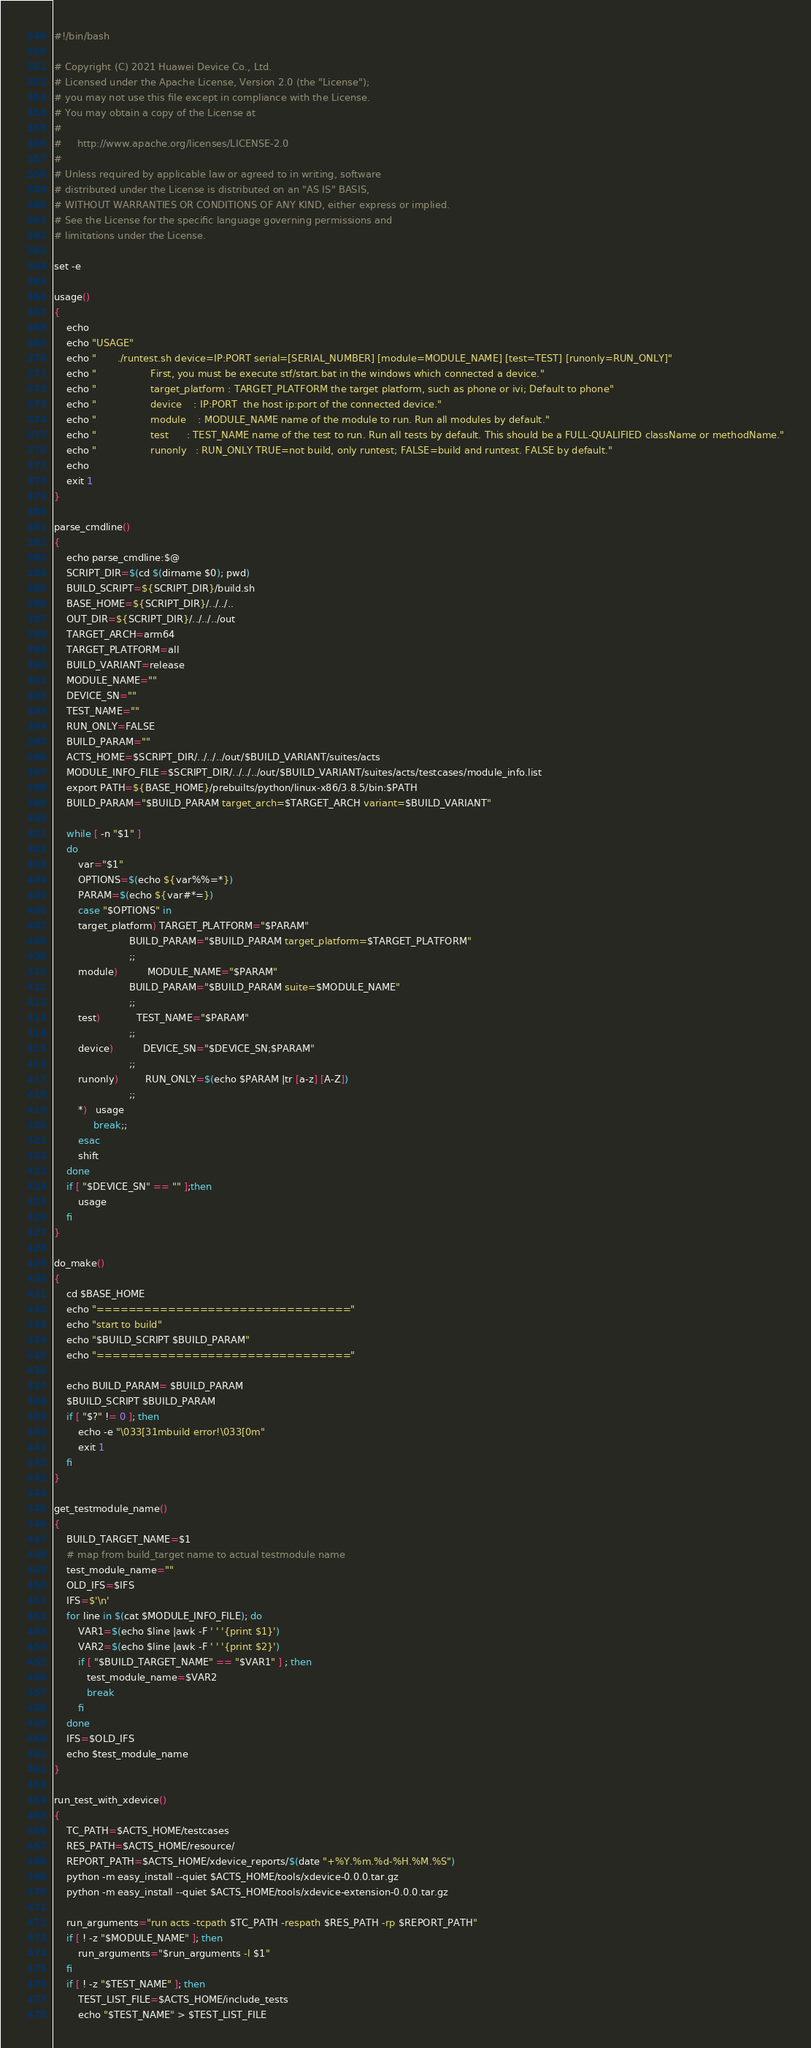Convert code to text. <code><loc_0><loc_0><loc_500><loc_500><_Bash_>#!/bin/bash

# Copyright (C) 2021 Huawei Device Co., Ltd.
# Licensed under the Apache License, Version 2.0 (the "License");
# you may not use this file except in compliance with the License.
# You may obtain a copy of the License at
#
#     http://www.apache.org/licenses/LICENSE-2.0
#
# Unless required by applicable law or agreed to in writing, software
# distributed under the License is distributed on an "AS IS" BASIS,
# WITHOUT WARRANTIES OR CONDITIONS OF ANY KIND, either express or implied.
# See the License for the specific language governing permissions and
# limitations under the License.

set -e

usage()
{
    echo
    echo "USAGE"
    echo "       ./runtest.sh device=IP:PORT serial=[SERIAL_NUMBER] [module=MODULE_NAME] [test=TEST] [runonly=RUN_ONLY]"
    echo "                  First, you must be execute stf/start.bat in the windows which connected a device."
    echo "                  target_platform : TARGET_PLATFORM the target platform, such as phone or ivi; Default to phone"
    echo "                  device    : IP:PORT  the host ip:port of the connected device."
    echo "                  module    : MODULE_NAME name of the module to run. Run all modules by default."
    echo "                  test      : TEST_NAME name of the test to run. Run all tests by default. This should be a FULL-QUALIFIED className or methodName."
    echo "                  runonly   : RUN_ONLY TRUE=not build, only runtest; FALSE=build and runtest. FALSE by default."
    echo
    exit 1
}

parse_cmdline()
{
    echo parse_cmdline:$@
    SCRIPT_DIR=$(cd $(dirname $0); pwd)
    BUILD_SCRIPT=${SCRIPT_DIR}/build.sh
    BASE_HOME=${SCRIPT_DIR}/../../..
    OUT_DIR=${SCRIPT_DIR}/../../../out
    TARGET_ARCH=arm64
    TARGET_PLATFORM=all
    BUILD_VARIANT=release
    MODULE_NAME=""
    DEVICE_SN=""
    TEST_NAME=""
    RUN_ONLY=FALSE
    BUILD_PARAM=""
    ACTS_HOME=$SCRIPT_DIR/../../../out/$BUILD_VARIANT/suites/acts
    MODULE_INFO_FILE=$SCRIPT_DIR/../../../out/$BUILD_VARIANT/suites/acts/testcases/module_info.list
    export PATH=${BASE_HOME}/prebuilts/python/linux-x86/3.8.5/bin:$PATH
    BUILD_PARAM="$BUILD_PARAM target_arch=$TARGET_ARCH variant=$BUILD_VARIANT"
    
    while [ -n "$1" ]
    do
        var="$1"
        OPTIONS=$(echo ${var%%=*})
        PARAM=$(echo ${var#*=})
        case "$OPTIONS" in
        target_platform) TARGET_PLATFORM="$PARAM"
                         BUILD_PARAM="$BUILD_PARAM target_platform=$TARGET_PLATFORM"
                         ;;
        module)          MODULE_NAME="$PARAM"
                         BUILD_PARAM="$BUILD_PARAM suite=$MODULE_NAME"
                         ;;
        test)            TEST_NAME="$PARAM"
                         ;;
        device)          DEVICE_SN="$DEVICE_SN;$PARAM"
                         ;;
        runonly)         RUN_ONLY=$(echo $PARAM |tr [a-z] [A-Z])
                         ;;
        *)   usage
             break;;
        esac
        shift
    done
    if [ "$DEVICE_SN" == "" ];then
        usage
    fi
}

do_make()
{
    cd $BASE_HOME
    echo "================================"
    echo "start to build"
    echo "$BUILD_SCRIPT $BUILD_PARAM"
    echo "================================"
    
    echo BUILD_PARAM= $BUILD_PARAM
    $BUILD_SCRIPT $BUILD_PARAM
    if [ "$?" != 0 ]; then
        echo -e "\033[31mbuild error!\033[0m"
        exit 1
    fi
}

get_testmodule_name()
{
    BUILD_TARGET_NAME=$1
    # map from build_target name to actual testmodule name
    test_module_name=""
    OLD_IFS=$IFS
    IFS=$'\n'
    for line in $(cat $MODULE_INFO_FILE); do
        VAR1=$(echo $line |awk -F ' ' '{print $1}')
        VAR2=$(echo $line |awk -F ' ' '{print $2}')
        if [ "$BUILD_TARGET_NAME" == "$VAR1" ] ; then
           test_module_name=$VAR2
           break
        fi
    done
    IFS=$OLD_IFS
    echo $test_module_name
}

run_test_with_xdevice()
{
    TC_PATH=$ACTS_HOME/testcases
    RES_PATH=$ACTS_HOME/resource/
    REPORT_PATH=$ACTS_HOME/xdevice_reports/$(date "+%Y.%m.%d-%H.%M.%S")
    python -m easy_install --quiet $ACTS_HOME/tools/xdevice-0.0.0.tar.gz
    python -m easy_install --quiet $ACTS_HOME/tools/xdevice-extension-0.0.0.tar.gz

    run_arguments="run acts -tcpath $TC_PATH -respath $RES_PATH -rp $REPORT_PATH"
    if [ ! -z "$MODULE_NAME" ]; then
        run_arguments="$run_arguments -l $1"
    fi
    if [ ! -z "$TEST_NAME" ]; then
        TEST_LIST_FILE=$ACTS_HOME/include_tests
        echo "$TEST_NAME" > $TEST_LIST_FILE</code> 